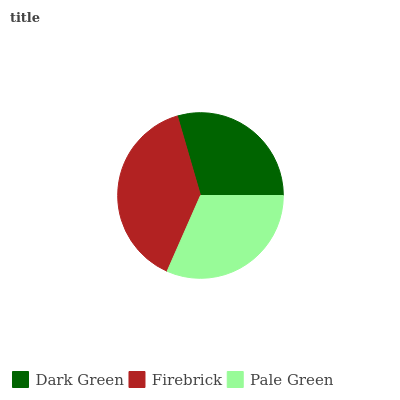Is Dark Green the minimum?
Answer yes or no. Yes. Is Firebrick the maximum?
Answer yes or no. Yes. Is Pale Green the minimum?
Answer yes or no. No. Is Pale Green the maximum?
Answer yes or no. No. Is Firebrick greater than Pale Green?
Answer yes or no. Yes. Is Pale Green less than Firebrick?
Answer yes or no. Yes. Is Pale Green greater than Firebrick?
Answer yes or no. No. Is Firebrick less than Pale Green?
Answer yes or no. No. Is Pale Green the high median?
Answer yes or no. Yes. Is Pale Green the low median?
Answer yes or no. Yes. Is Firebrick the high median?
Answer yes or no. No. Is Firebrick the low median?
Answer yes or no. No. 